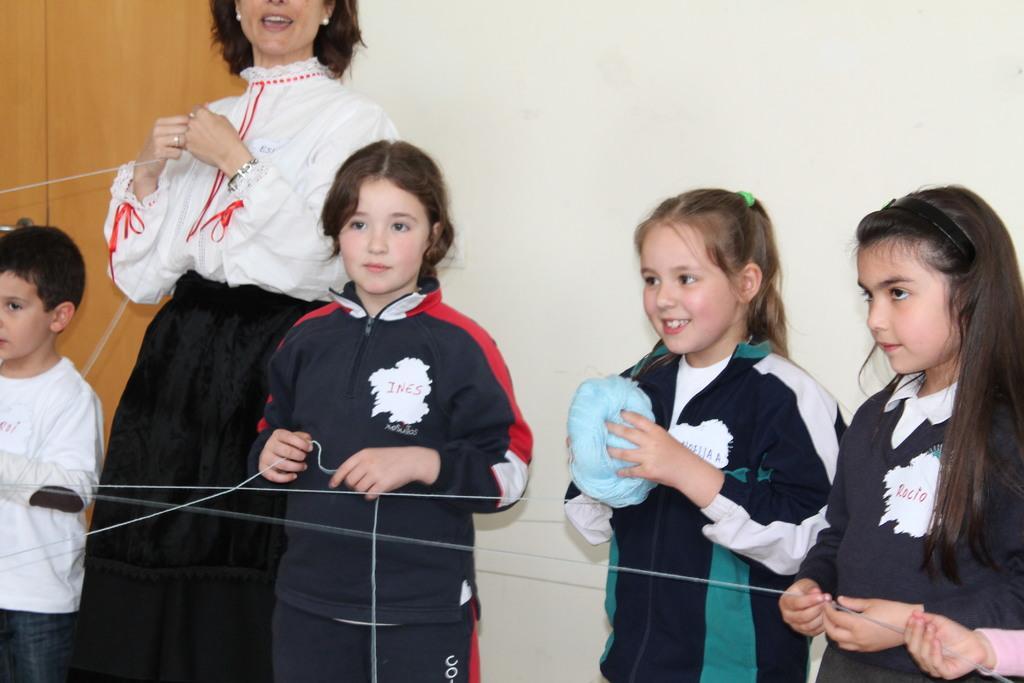How would you summarize this image in a sentence or two? In the picture there is a woman and a group of kids, they are holding a thread and one of the kid is holding a thread roll, in the background there is a wall. 